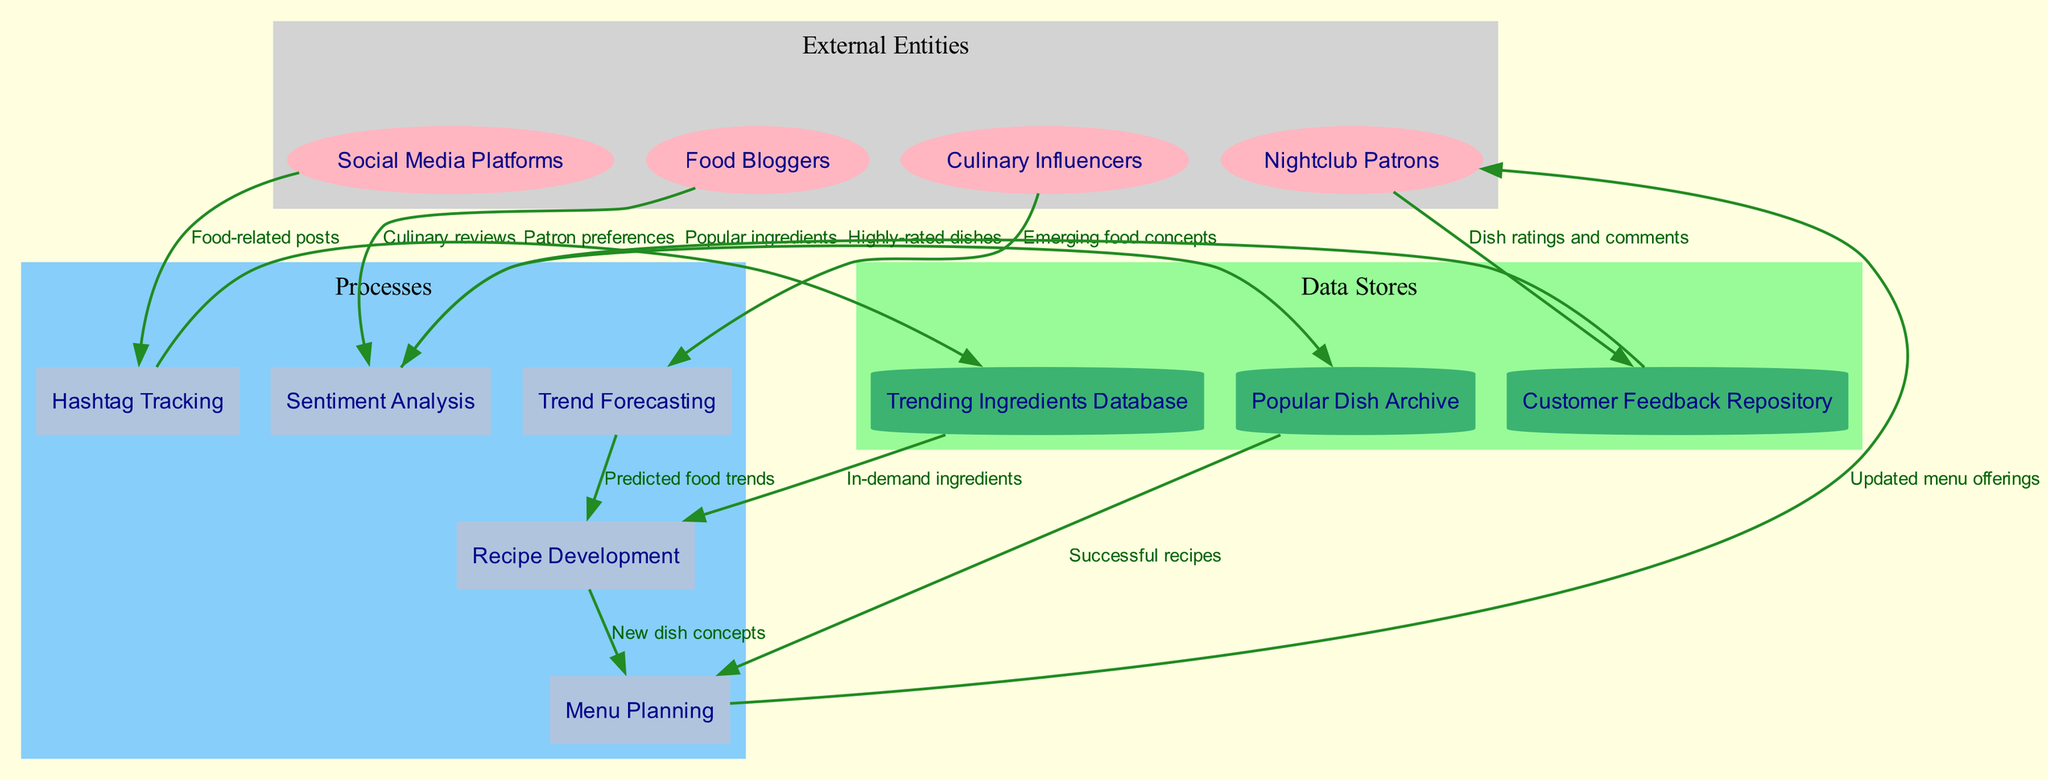What are the external entities in the diagram? The external entities listed in the diagram are shown in a specific subgraph labeled ‘External Entities.’ The entities include "Social Media Platforms," "Food Bloggers," "Culinary Influencers," and "Nightclub Patrons."
Answer: Social Media Platforms, Food Bloggers, Culinary Influencers, Nightclub Patrons How many processes are in the diagram? The number of processes is counted directly from the 'Processes' subgraph. There are five processes listed: "Hashtag Tracking," "Sentiment Analysis," "Trend Forecasting," "Recipe Development," and "Menu Planning."
Answer: 5 Which data store is linked to "Menu Planning"? To find which data store is connected to "Menu Planning," we can trace the edges leading from 'Menu Planning', specifically one that shows the flow from "Popular Dish Archive" to "Menu Planning." Therefore, "Menu Planning" receives data from that store.
Answer: Popular Dish Archive What type of data flows into the "Sentiment Analysis" process? The 'Sentiment Analysis' process receives data labeled "Culinary reviews" from "Food Bloggers." This clear flow is indicated in the diagram by the connecting edge.
Answer: Culinary reviews What influences the "Recipe Development" process? The "Recipe Development" process receives data flows from two sources: one is "Predicted food trends" from "Trend Forecasting," and the other is "In-demand ingredients" from the "Trending Ingredients Database." Both flows are critical for recipe innovation.
Answer: Predicted food trends, In-demand ingredients How does customer feedback contribute to the processes? Customer feedback from "Nightclub Patrons" flows into the "Customer Feedback Repository," which then influences "Sentiment Analysis" with patron preferences. This sequence illustrates how direct feedback from customers ultimately shapes the culinary insights processed later.
Answer: Patron preferences Which process generates new dish concepts for the menu? The "Recipe Development" process creates new dish concepts, which are then passed on to the "Menu Planning" process. The flow indicates that it is a key step in designing menu offerings.
Answer: Recipe Development How many data stores are depicted in the diagram? The count of data stores can be seen in the 'Data Stores' subgraph, where three data stores are listed: "Trending Ingredients Database," "Popular Dish Archive," and "Customer Feedback Repository."
Answer: 3 Which external entity provides "Food-related posts" to the system? The "Food-related posts" are received from "Social Media Platforms," as indicated by the labeled edge in the diagram that connects to the "Hashtag Tracking" process.
Answer: Social Media Platforms 